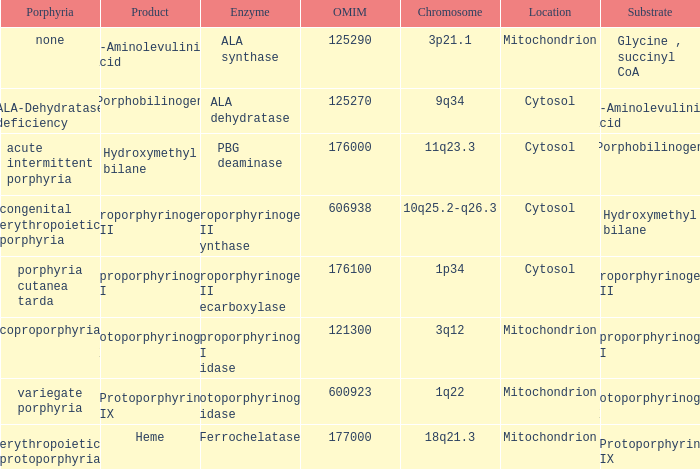What is the location of the enzyme Uroporphyrinogen iii Synthase? Cytosol. 